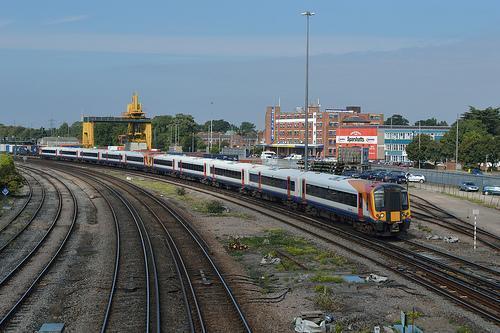How many trains are there?
Give a very brief answer. 1. 